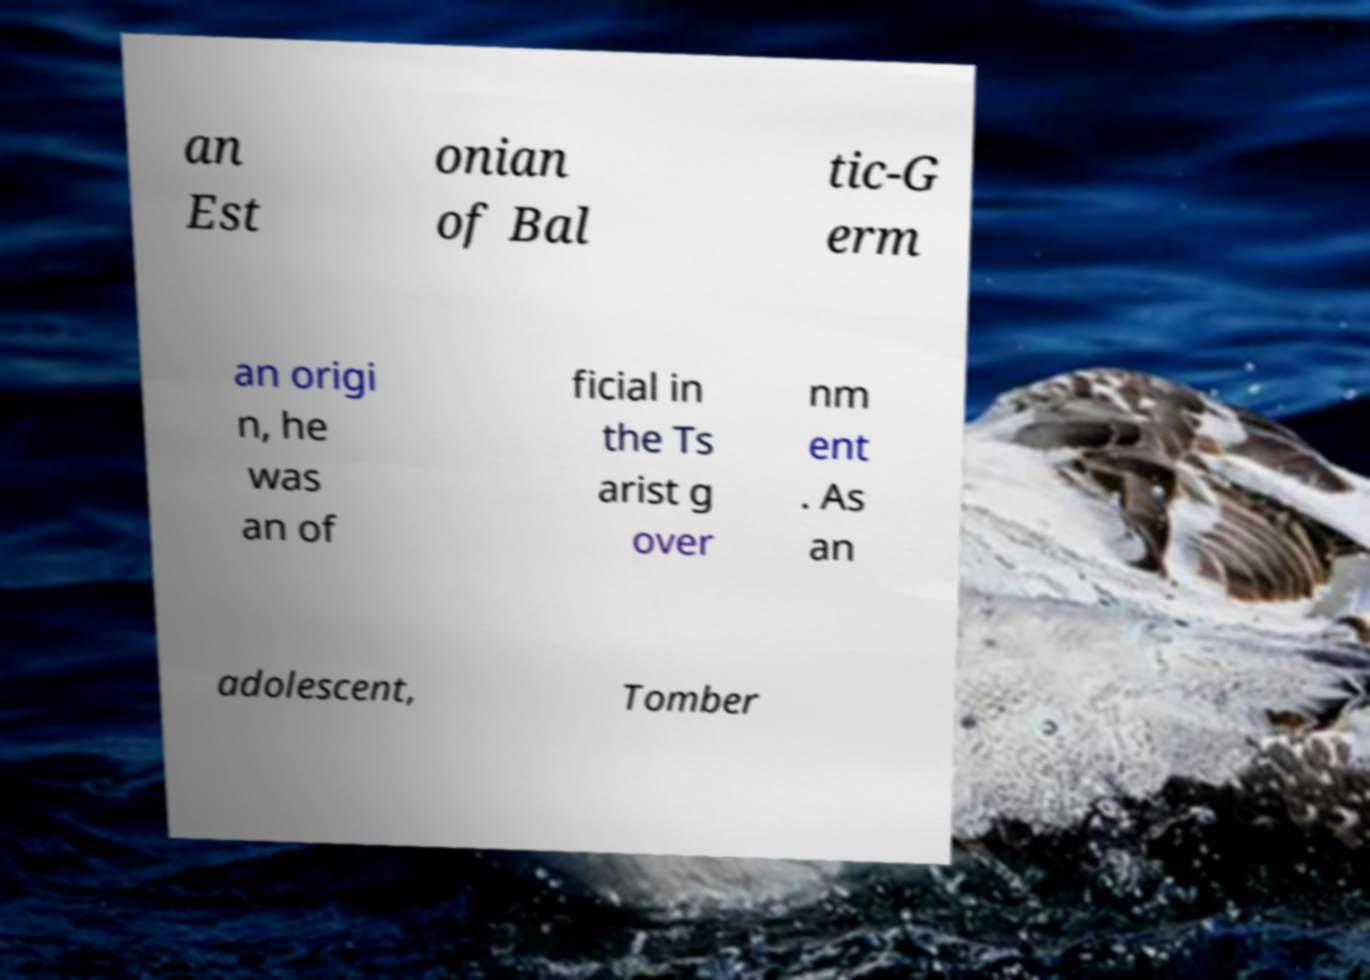Can you read and provide the text displayed in the image?This photo seems to have some interesting text. Can you extract and type it out for me? an Est onian of Bal tic-G erm an origi n, he was an of ficial in the Ts arist g over nm ent . As an adolescent, Tomber 